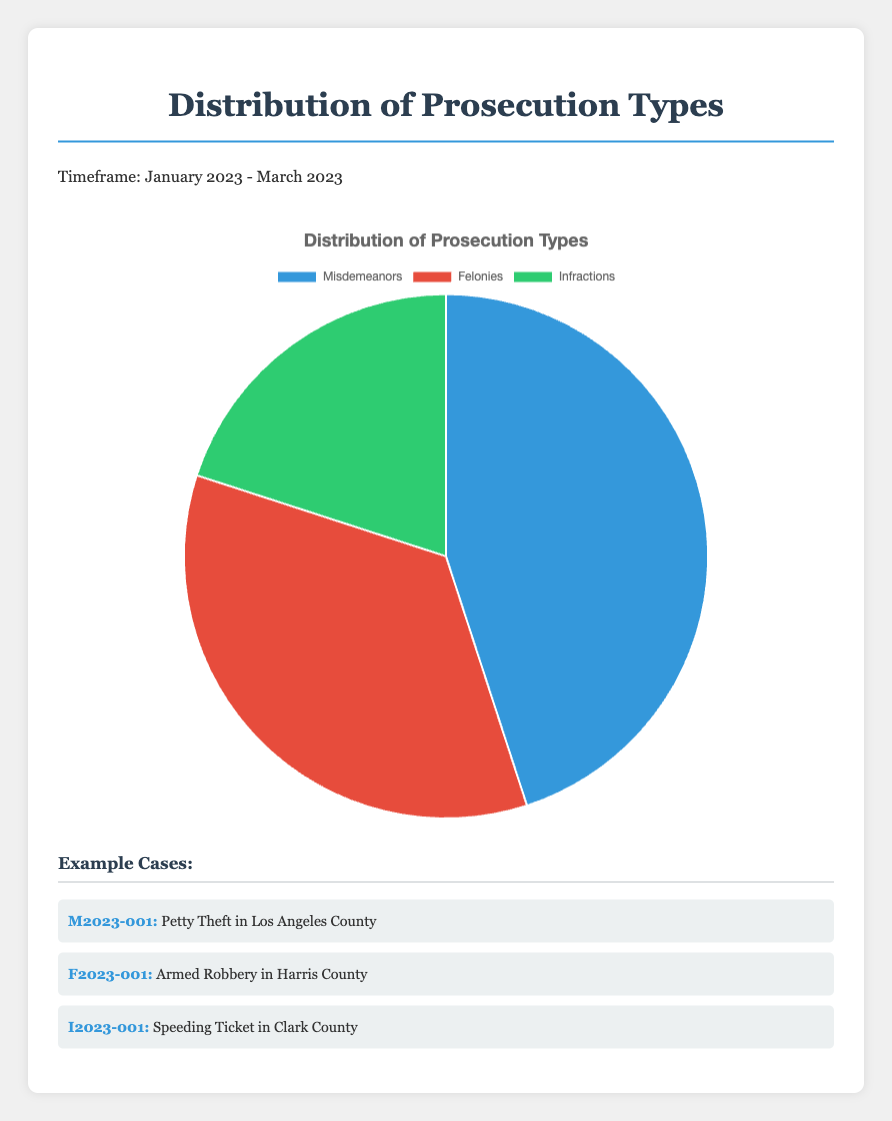What percentage of prosecution cases were misdemeanors from January 2023 to March 2023? The pie chart shows the distribution of different types of prosecutions within the specified timeframe. The section of the chart for misdemeanors indicates 45%.
Answer: 45% Which type of prosecution had the lowest percentage? By examining the pie chart, you can see that infractions occupy the smallest segment, representing 20% of the total prosecutions, which is less than that of misdemeanors and felonies.
Answer: Infractions How much greater is the percentage of misdemeanors compared to felonies? The chart shows misdemeanors at 45% and felonies at 35%. The difference between them is 45% - 35% = 10%.
Answer: 10% Which color represents felonies, and what is its percentage? In the pie chart, the segment representing felonies is colored red, and the percentage indicated is 35%.
Answer: Red, 35% If infractions increased by 10%, and all other percentages remained the same, what would be the new percentage of infractions? Initially, infractions are at 20%. Adding 10% to this value results in 20% + 10% = 30%.
Answer: 30% What is the combined percentage of misdemeanors and infractions? The percentage for misdemeanors is 45%, and for infractions, it is 20%. The combined percentage is 45% + 20% = 65%.
Answer: 65% Rank the prosecution types from most to least common based on the percentages shown. Observing the pie chart, misdemeanors are shown as the largest segment at 45%, followed by felonies at 35%, and infractions as the smallest at 20%. Therefore, the ranking from most to least common is misdemeanors, felonies, infractions.
Answer: Misdemeanors, Felonies, Infractions How many more percentage points are misdemeanors compared to infractions? The percentage of misdemeanors is 45%, while infractions are 20%. The difference is calculated as 45% - 20% = 25%.
Answer: 25% Calculate the percentage difference between felonies and infractions. Felonies are at 35%, while infractions are at 20%. The percentage difference is 35% - 20% = 15%.
Answer: 15% If the total number of prosecution cases is 2000, how many of those were felonies? With felonies making up 35% of the total cases and the total being 2000, the number of felony cases can be calculated as 35/100 * 2000 = 700 cases.
Answer: 700 